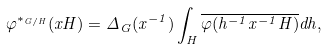Convert formula to latex. <formula><loc_0><loc_0><loc_500><loc_500>\varphi ^ { \ast _ { G / H } } ( x H ) = \Delta _ { G } ( x ^ { - 1 } ) \int _ { H } \overline { \varphi ( h ^ { - 1 } x ^ { - 1 } H ) } d h ,</formula> 